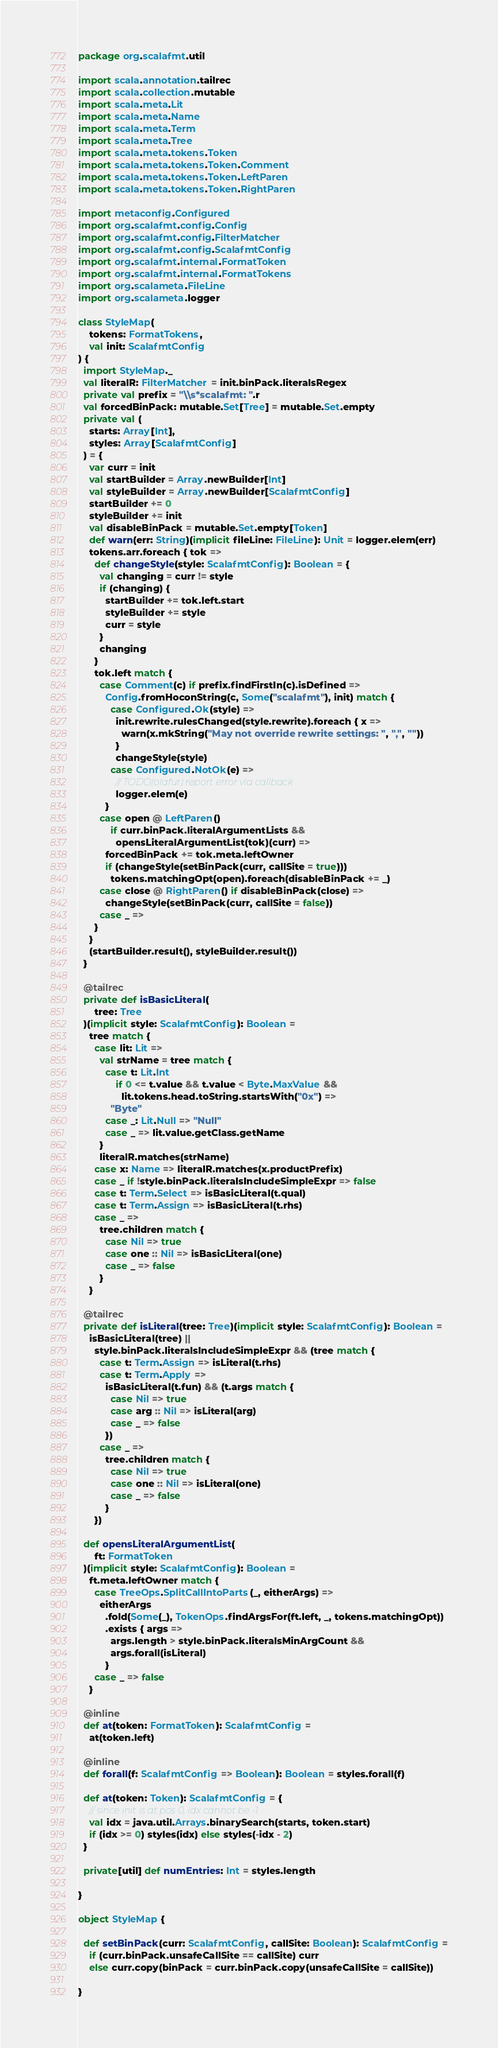<code> <loc_0><loc_0><loc_500><loc_500><_Scala_>package org.scalafmt.util

import scala.annotation.tailrec
import scala.collection.mutable
import scala.meta.Lit
import scala.meta.Name
import scala.meta.Term
import scala.meta.Tree
import scala.meta.tokens.Token
import scala.meta.tokens.Token.Comment
import scala.meta.tokens.Token.LeftParen
import scala.meta.tokens.Token.RightParen

import metaconfig.Configured
import org.scalafmt.config.Config
import org.scalafmt.config.FilterMatcher
import org.scalafmt.config.ScalafmtConfig
import org.scalafmt.internal.FormatToken
import org.scalafmt.internal.FormatTokens
import org.scalameta.FileLine
import org.scalameta.logger

class StyleMap(
    tokens: FormatTokens,
    val init: ScalafmtConfig
) {
  import StyleMap._
  val literalR: FilterMatcher = init.binPack.literalsRegex
  private val prefix = "\\s*scalafmt: ".r
  val forcedBinPack: mutable.Set[Tree] = mutable.Set.empty
  private val (
    starts: Array[Int],
    styles: Array[ScalafmtConfig]
  ) = {
    var curr = init
    val startBuilder = Array.newBuilder[Int]
    val styleBuilder = Array.newBuilder[ScalafmtConfig]
    startBuilder += 0
    styleBuilder += init
    val disableBinPack = mutable.Set.empty[Token]
    def warn(err: String)(implicit fileLine: FileLine): Unit = logger.elem(err)
    tokens.arr.foreach { tok =>
      def changeStyle(style: ScalafmtConfig): Boolean = {
        val changing = curr != style
        if (changing) {
          startBuilder += tok.left.start
          styleBuilder += style
          curr = style
        }
        changing
      }
      tok.left match {
        case Comment(c) if prefix.findFirstIn(c).isDefined =>
          Config.fromHoconString(c, Some("scalafmt"), init) match {
            case Configured.Ok(style) =>
              init.rewrite.rulesChanged(style.rewrite).foreach { x =>
                warn(x.mkString("May not override rewrite settings: ", ",", ""))
              }
              changeStyle(style)
            case Configured.NotOk(e) =>
              // TODO(olafur) report error via callback
              logger.elem(e)
          }
        case open @ LeftParen()
            if curr.binPack.literalArgumentLists &&
              opensLiteralArgumentList(tok)(curr) =>
          forcedBinPack += tok.meta.leftOwner
          if (changeStyle(setBinPack(curr, callSite = true)))
            tokens.matchingOpt(open).foreach(disableBinPack += _)
        case close @ RightParen() if disableBinPack(close) =>
          changeStyle(setBinPack(curr, callSite = false))
        case _ =>
      }
    }
    (startBuilder.result(), styleBuilder.result())
  }

  @tailrec
  private def isBasicLiteral(
      tree: Tree
  )(implicit style: ScalafmtConfig): Boolean =
    tree match {
      case lit: Lit =>
        val strName = tree match {
          case t: Lit.Int
              if 0 <= t.value && t.value < Byte.MaxValue &&
                lit.tokens.head.toString.startsWith("0x") =>
            "Byte"
          case _: Lit.Null => "Null"
          case _ => lit.value.getClass.getName
        }
        literalR.matches(strName)
      case x: Name => literalR.matches(x.productPrefix)
      case _ if !style.binPack.literalsIncludeSimpleExpr => false
      case t: Term.Select => isBasicLiteral(t.qual)
      case t: Term.Assign => isBasicLiteral(t.rhs)
      case _ =>
        tree.children match {
          case Nil => true
          case one :: Nil => isBasicLiteral(one)
          case _ => false
        }
    }

  @tailrec
  private def isLiteral(tree: Tree)(implicit style: ScalafmtConfig): Boolean =
    isBasicLiteral(tree) ||
      style.binPack.literalsIncludeSimpleExpr && (tree match {
        case t: Term.Assign => isLiteral(t.rhs)
        case t: Term.Apply =>
          isBasicLiteral(t.fun) && (t.args match {
            case Nil => true
            case arg :: Nil => isLiteral(arg)
            case _ => false
          })
        case _ =>
          tree.children match {
            case Nil => true
            case one :: Nil => isLiteral(one)
            case _ => false
          }
      })

  def opensLiteralArgumentList(
      ft: FormatToken
  )(implicit style: ScalafmtConfig): Boolean =
    ft.meta.leftOwner match {
      case TreeOps.SplitCallIntoParts(_, eitherArgs) =>
        eitherArgs
          .fold(Some(_), TokenOps.findArgsFor(ft.left, _, tokens.matchingOpt))
          .exists { args =>
            args.length > style.binPack.literalsMinArgCount &&
            args.forall(isLiteral)
          }
      case _ => false
    }

  @inline
  def at(token: FormatToken): ScalafmtConfig =
    at(token.left)

  @inline
  def forall(f: ScalafmtConfig => Boolean): Boolean = styles.forall(f)

  def at(token: Token): ScalafmtConfig = {
    // since init is at pos 0, idx cannot be -1
    val idx = java.util.Arrays.binarySearch(starts, token.start)
    if (idx >= 0) styles(idx) else styles(-idx - 2)
  }

  private[util] def numEntries: Int = styles.length

}

object StyleMap {

  def setBinPack(curr: ScalafmtConfig, callSite: Boolean): ScalafmtConfig =
    if (curr.binPack.unsafeCallSite == callSite) curr
    else curr.copy(binPack = curr.binPack.copy(unsafeCallSite = callSite))

}
</code> 